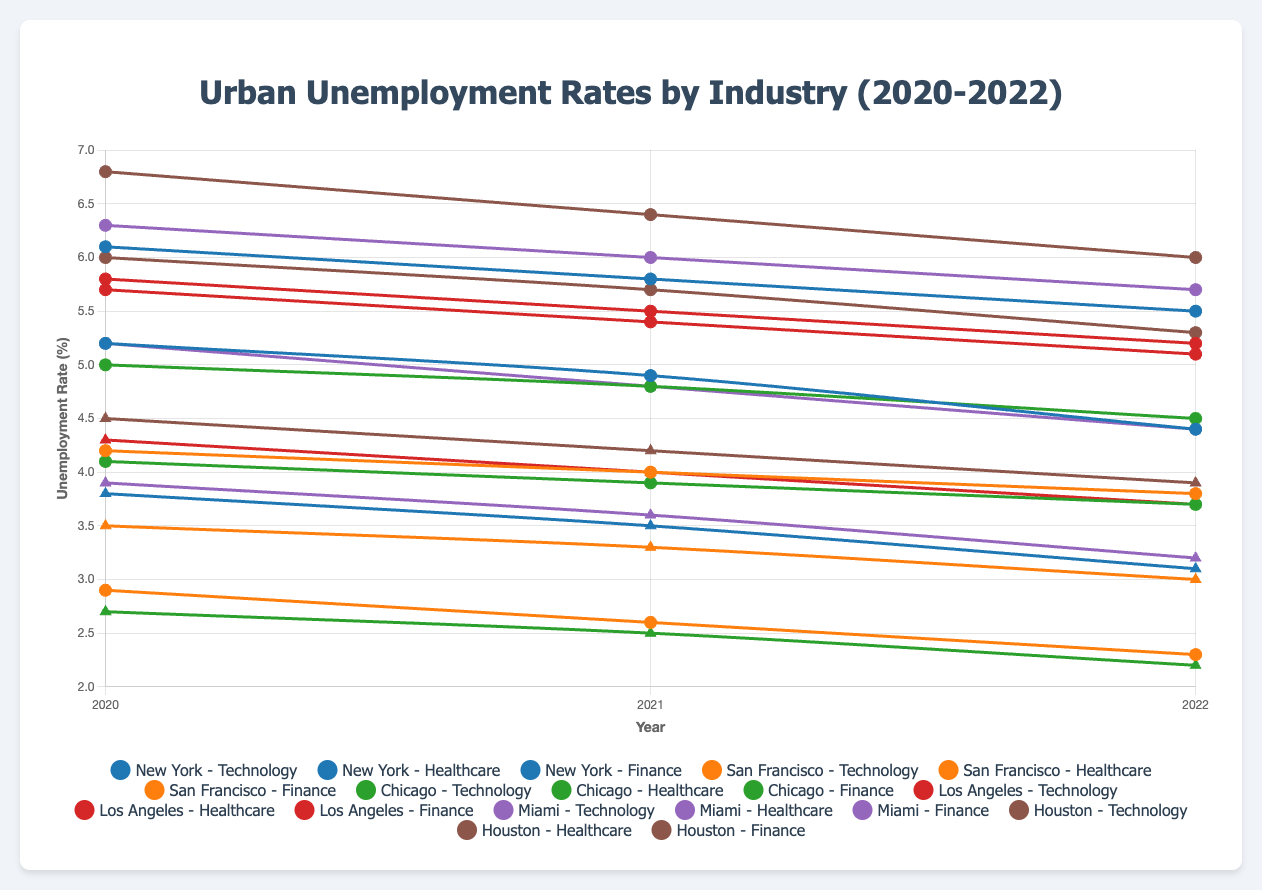Which city had the highest unemployment rate in 2022 in the Finance sector? By examining the unemployment rates in the Finance sector for each city in 2022, we can see that Houston had the highest rate at 6.0%.
Answer: Houston Which industry saw the largest decrease in unemployment rate in New York from 2020 to 2022? For New York, we calculate the differences between the rates in 2020 and 2022 for each industry: Technology (5.2 - 4.4 = 0.8), Healthcare (3.8 - 3.1 = 0.7), and Finance (6.1 - 5.5 = 0.6). The Technology industry saw the largest decrease with a reduction of 0.8%.
Answer: Technology Between 2020 and 2022, which city had the smallest absolute change in unemployment rate for the Healthcare industry? We find the absolute changes in each city's Healthcare industry: New York (3.8 - 3.1 = 0.7), San Francisco (3.5 - 3.0 = 0.5), Chicago (2.7 - 2.2 = 0.5), Los Angeles (4.3 - 3.7 = 0.6), Miami (3.9 - 3.2 = 0.7), and Houston (4.5 - 3.9 = 0.6). San Francisco and Chicago both had the smallest change of 0.5.
Answer: San Francisco and Chicago Which city showed the steadiest decrease in unemployment rate for the Technology sector from 2020 to 2022? We assess the year-over-year changes in the Technology sector unemployment rates. San Francisco consistently drops by 0.3 each year (2.9 to 2.6, then 2.6 to 2.3). Thus, San Francisco shows the steadiest decrease.
Answer: San Francisco In 2021, which city had a higher unemployment rate in the Healthcare sector: Miami or Houston? Comparing the 2021 Healthcare sector rates, Miami had a rate of 3.6%, while Houston had a rate of 4.2%. Therefore, Houston had a higher rate.
Answer: Houston What is the average unemployment rate in Los Angeles for the Finance sector over the three years? Adding the rates for 2020, 2021, and 2022 (5.8 + 5.5 + 5.2) gives 16.5. Dividing by 3 gives an average of 5.5.
Answer: 5.5 Which industry in Chicago had the lowest unemployment rate in 2022? Examining the 2022 rates for Chicago: Technology (3.7), Healthcare (2.2), and Finance (4.5), the Healthcare sector had the lowest rate at 2.2%.
Answer: Healthcare How much did the unemployment rate for the Technology sector in Houston drop by from 2020 to 2022? Subtracting the 2022 rate from the 2020 rate for Houston in the Technology sector (6.0 - 5.3) gives a drop of 0.7%.
Answer: 0.7 Which city had a lower Technology sector unemployment rate in 2021: Chicago or Miami? Comparing the 2021 Technology sector rates, Chicago had a rate of 3.9%, while Miami had a rate of 4.8%. Therefore, Chicago had a lower rate.
Answer: Chicago In 2022, was the unemployment rate in the Healthcare sector lower in New York or Los Angeles? Comparing the 2022 Healthcare sector rates, New York had a rate of 3.1%, while Los Angeles had a rate of 3.7%. Thus, New York had a lower rate.
Answer: New York 